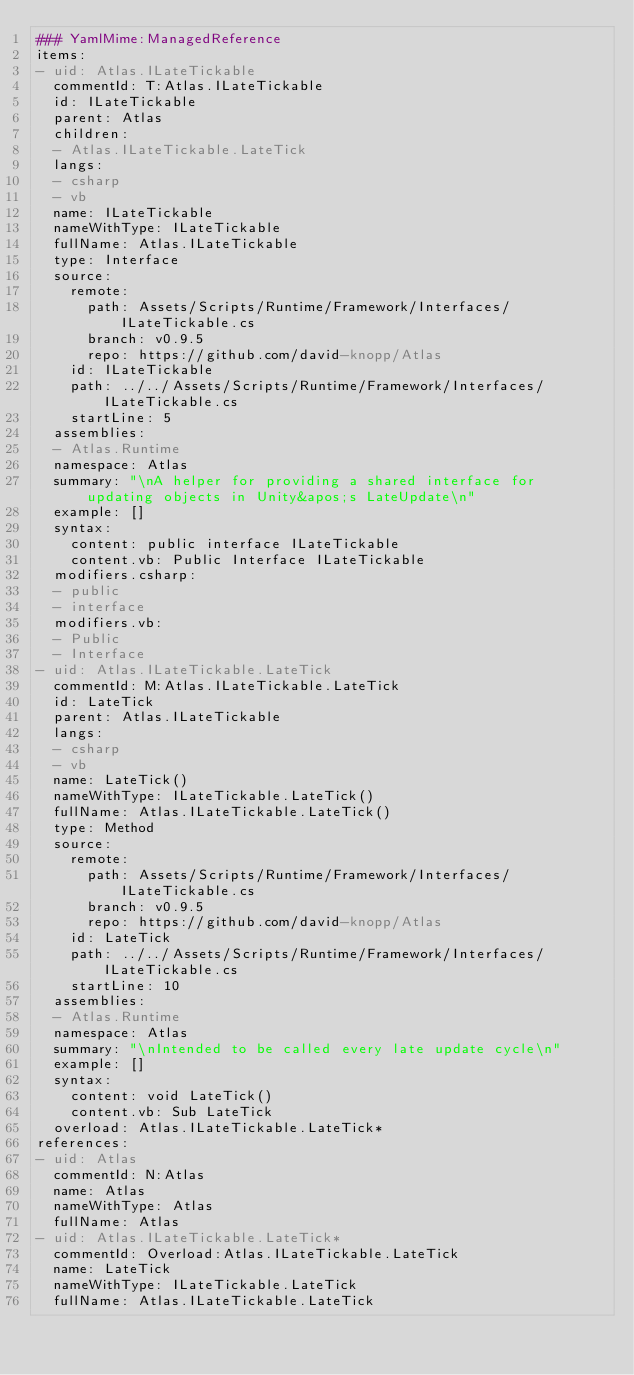Convert code to text. <code><loc_0><loc_0><loc_500><loc_500><_YAML_>### YamlMime:ManagedReference
items:
- uid: Atlas.ILateTickable
  commentId: T:Atlas.ILateTickable
  id: ILateTickable
  parent: Atlas
  children:
  - Atlas.ILateTickable.LateTick
  langs:
  - csharp
  - vb
  name: ILateTickable
  nameWithType: ILateTickable
  fullName: Atlas.ILateTickable
  type: Interface
  source:
    remote:
      path: Assets/Scripts/Runtime/Framework/Interfaces/ILateTickable.cs
      branch: v0.9.5
      repo: https://github.com/david-knopp/Atlas
    id: ILateTickable
    path: ../../Assets/Scripts/Runtime/Framework/Interfaces/ILateTickable.cs
    startLine: 5
  assemblies:
  - Atlas.Runtime
  namespace: Atlas
  summary: "\nA helper for providing a shared interface for updating objects in Unity&apos;s LateUpdate\n"
  example: []
  syntax:
    content: public interface ILateTickable
    content.vb: Public Interface ILateTickable
  modifiers.csharp:
  - public
  - interface
  modifiers.vb:
  - Public
  - Interface
- uid: Atlas.ILateTickable.LateTick
  commentId: M:Atlas.ILateTickable.LateTick
  id: LateTick
  parent: Atlas.ILateTickable
  langs:
  - csharp
  - vb
  name: LateTick()
  nameWithType: ILateTickable.LateTick()
  fullName: Atlas.ILateTickable.LateTick()
  type: Method
  source:
    remote:
      path: Assets/Scripts/Runtime/Framework/Interfaces/ILateTickable.cs
      branch: v0.9.5
      repo: https://github.com/david-knopp/Atlas
    id: LateTick
    path: ../../Assets/Scripts/Runtime/Framework/Interfaces/ILateTickable.cs
    startLine: 10
  assemblies:
  - Atlas.Runtime
  namespace: Atlas
  summary: "\nIntended to be called every late update cycle\n"
  example: []
  syntax:
    content: void LateTick()
    content.vb: Sub LateTick
  overload: Atlas.ILateTickable.LateTick*
references:
- uid: Atlas
  commentId: N:Atlas
  name: Atlas
  nameWithType: Atlas
  fullName: Atlas
- uid: Atlas.ILateTickable.LateTick*
  commentId: Overload:Atlas.ILateTickable.LateTick
  name: LateTick
  nameWithType: ILateTickable.LateTick
  fullName: Atlas.ILateTickable.LateTick
</code> 